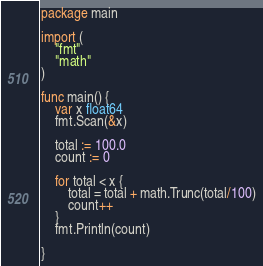Convert code to text. <code><loc_0><loc_0><loc_500><loc_500><_Go_>package main

import (
	"fmt"
	"math"
)

func main() {
	var x float64
	fmt.Scan(&x)

	total := 100.0
	count := 0

	for total < x {
		total = total + math.Trunc(total/100)
		count++
	}
	fmt.Println(count)

}
</code> 